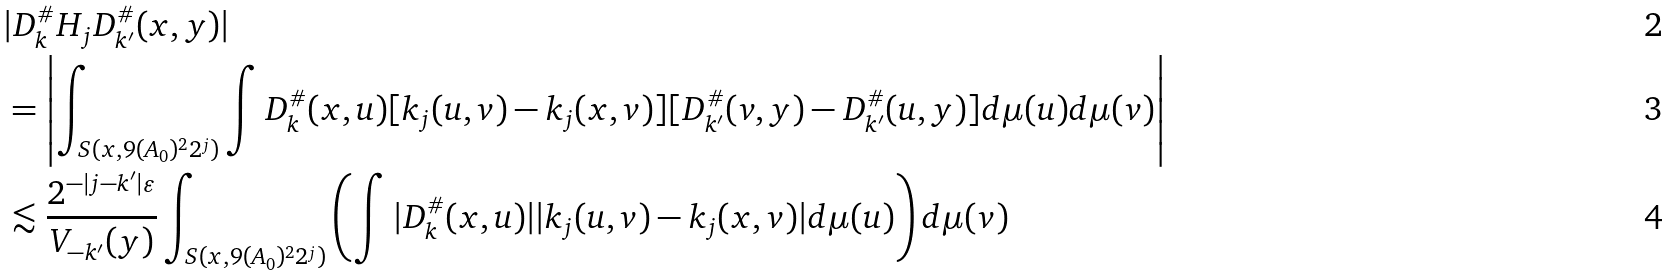<formula> <loc_0><loc_0><loc_500><loc_500>& | D _ { k } ^ { \# } H _ { j } D _ { k ^ { \prime } } ^ { \# } ( x , y ) | \\ & = \left | \int _ { S ( x , 9 ( A _ { 0 } ) ^ { 2 } 2 ^ { j } ) } \int D _ { k } ^ { \# } ( x , u ) [ k _ { j } ( u , v ) - k _ { j } ( x , v ) ] [ D _ { k ^ { \prime } } ^ { \# } ( v , y ) - D _ { k ^ { \prime } } ^ { \# } ( u , y ) ] d \mu ( u ) d \mu ( v ) \right | \\ & \lesssim \frac { 2 ^ { - | j - k ^ { \prime } | \varepsilon } } { V _ { - k ^ { \prime } } ( y ) } \int _ { S ( x , 9 ( A _ { 0 } ) ^ { 2 } 2 ^ { j } ) } \left ( \int | D _ { k } ^ { \# } ( x , u ) | | k _ { j } ( u , v ) - k _ { j } ( x , v ) | d \mu ( u ) \right ) d \mu ( v )</formula> 